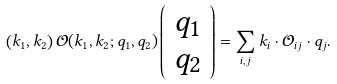<formula> <loc_0><loc_0><loc_500><loc_500>\left ( k _ { 1 } , k _ { 2 } \right ) \mathcal { O } ( k _ { 1 } , k _ { 2 } ; q _ { 1 } , q _ { 2 } ) \left ( \begin{array} { c } q _ { 1 } \\ q _ { 2 } \end{array} \right ) = \sum _ { i , j } k _ { i } \cdot \mathcal { O } _ { i j } \cdot q _ { j } .</formula> 